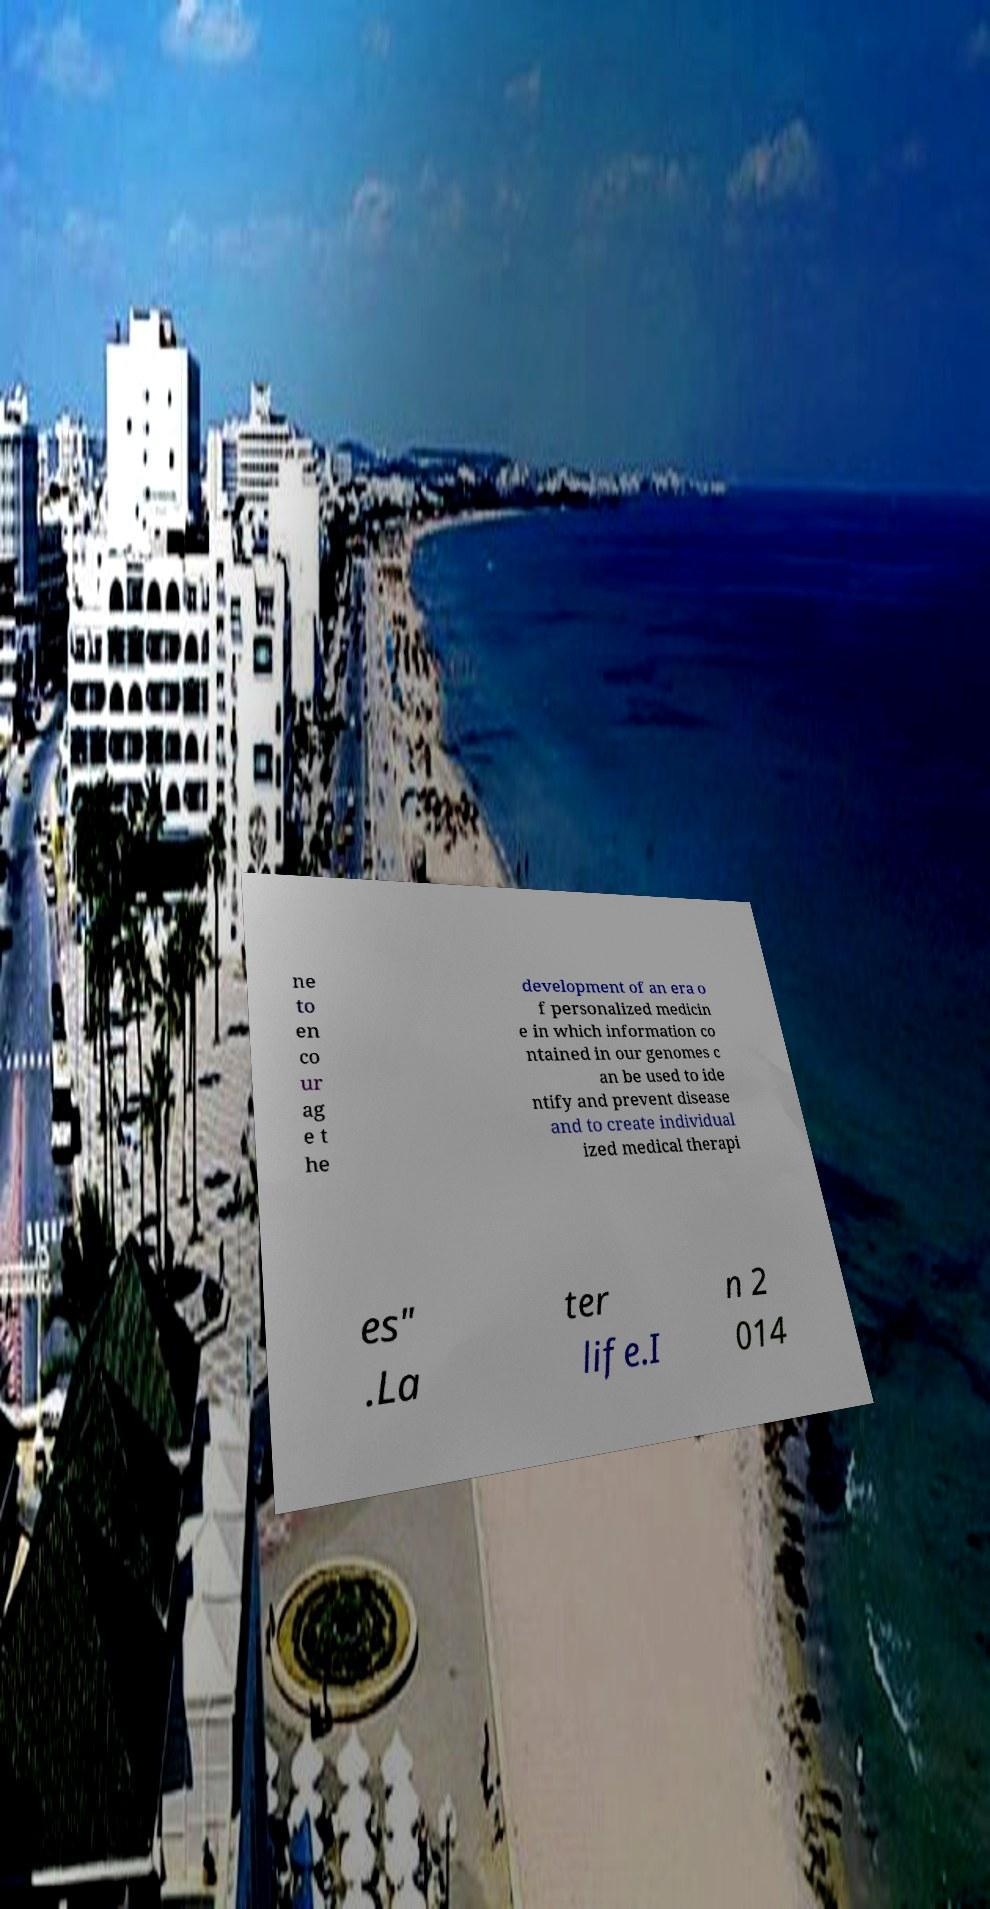Please read and relay the text visible in this image. What does it say? ne to en co ur ag e t he development of an era o f personalized medicin e in which information co ntained in our genomes c an be used to ide ntify and prevent disease and to create individual ized medical therapi es" .La ter life.I n 2 014 